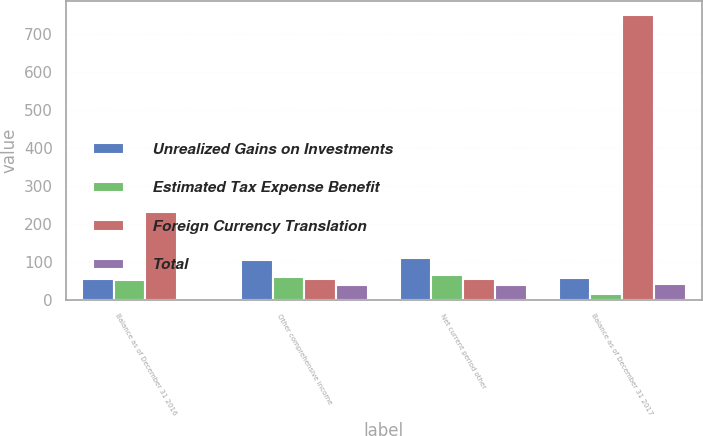Convert chart. <chart><loc_0><loc_0><loc_500><loc_500><stacked_bar_chart><ecel><fcel>Balance as of December 31 2016<fcel>Other comprehensive income<fcel>Net current period other<fcel>Balance as of December 31 2017<nl><fcel>Unrealized Gains on Investments<fcel>54<fcel>104<fcel>111<fcel>57<nl><fcel>Estimated Tax Expense Benefit<fcel>51<fcel>59<fcel>66<fcel>15<nl><fcel>Foreign Currency Translation<fcel>230<fcel>55.5<fcel>55.5<fcel>748<nl><fcel>Total<fcel>1<fcel>40<fcel>40<fcel>41<nl></chart> 